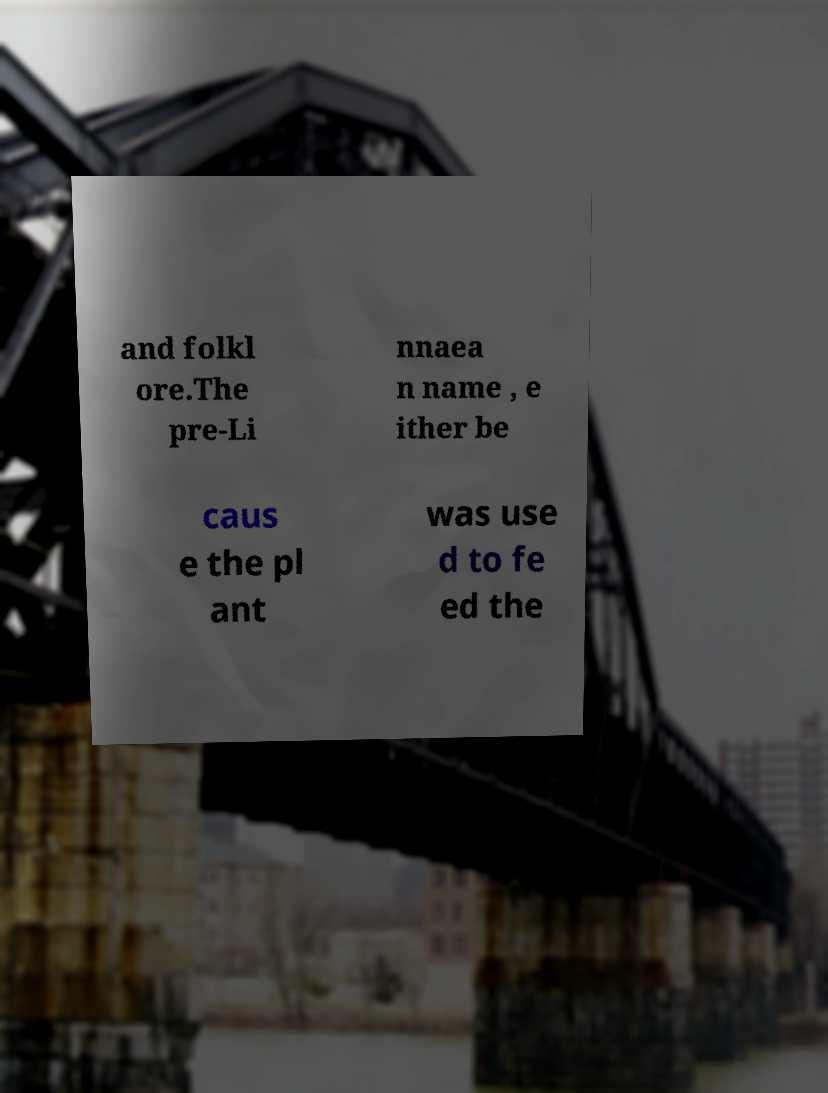Please read and relay the text visible in this image. What does it say? and folkl ore.The pre-Li nnaea n name , e ither be caus e the pl ant was use d to fe ed the 